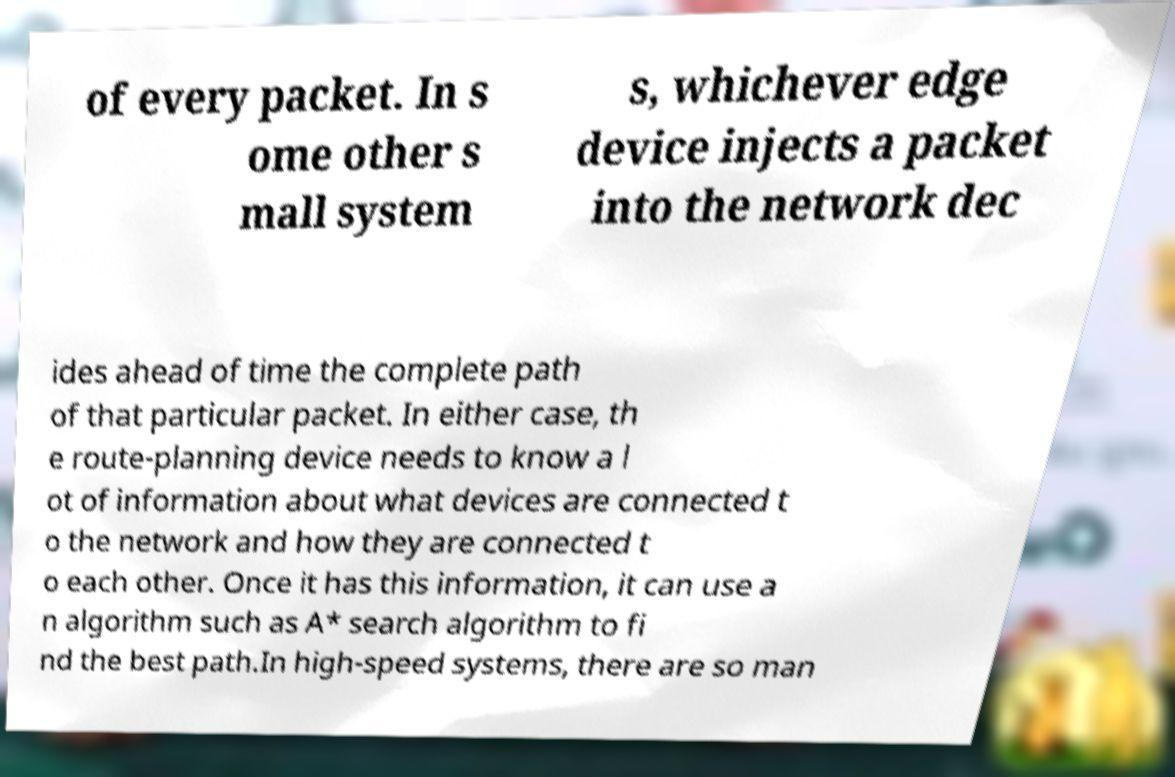For documentation purposes, I need the text within this image transcribed. Could you provide that? of every packet. In s ome other s mall system s, whichever edge device injects a packet into the network dec ides ahead of time the complete path of that particular packet. In either case, th e route-planning device needs to know a l ot of information about what devices are connected t o the network and how they are connected t o each other. Once it has this information, it can use a n algorithm such as A* search algorithm to fi nd the best path.In high-speed systems, there are so man 